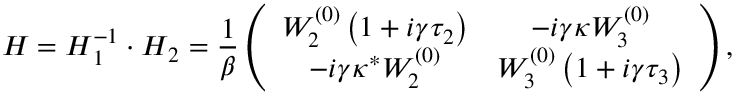Convert formula to latex. <formula><loc_0><loc_0><loc_500><loc_500>H = H _ { 1 } ^ { - 1 } \cdot H _ { 2 } = \frac { 1 } { \beta } \left ( \begin{array} { c c } { W _ { 2 } ^ { ( 0 ) } \left ( 1 + i \gamma \tau _ { 2 } \right ) } & { - i \gamma \kappa W _ { 3 } ^ { ( 0 ) } } \\ { - i \gamma \kappa ^ { * } W _ { 2 } ^ { ( 0 ) } } & { W _ { 3 } ^ { ( 0 ) } \left ( 1 + i \gamma \tau _ { 3 } \right ) } \end{array} \right ) ,</formula> 